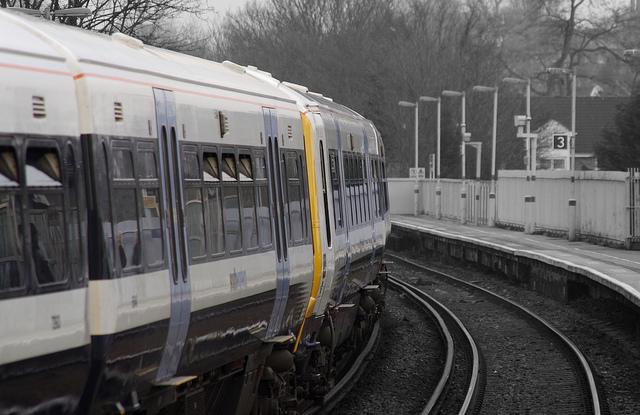How many of the train's windows are open?
Answer briefly. 5. What station is the train approaching?
Keep it brief. 3. Is it overcast?
Quick response, please. Yes. 